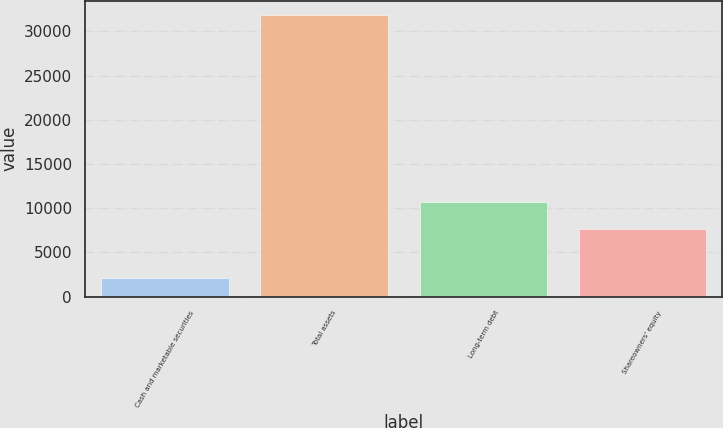Convert chart to OTSL. <chart><loc_0><loc_0><loc_500><loc_500><bar_chart><fcel>Cash and marketable securities<fcel>Total assets<fcel>Long-term debt<fcel>Shareowners' equity<nl><fcel>2100<fcel>31883<fcel>10674.3<fcel>7696<nl></chart> 